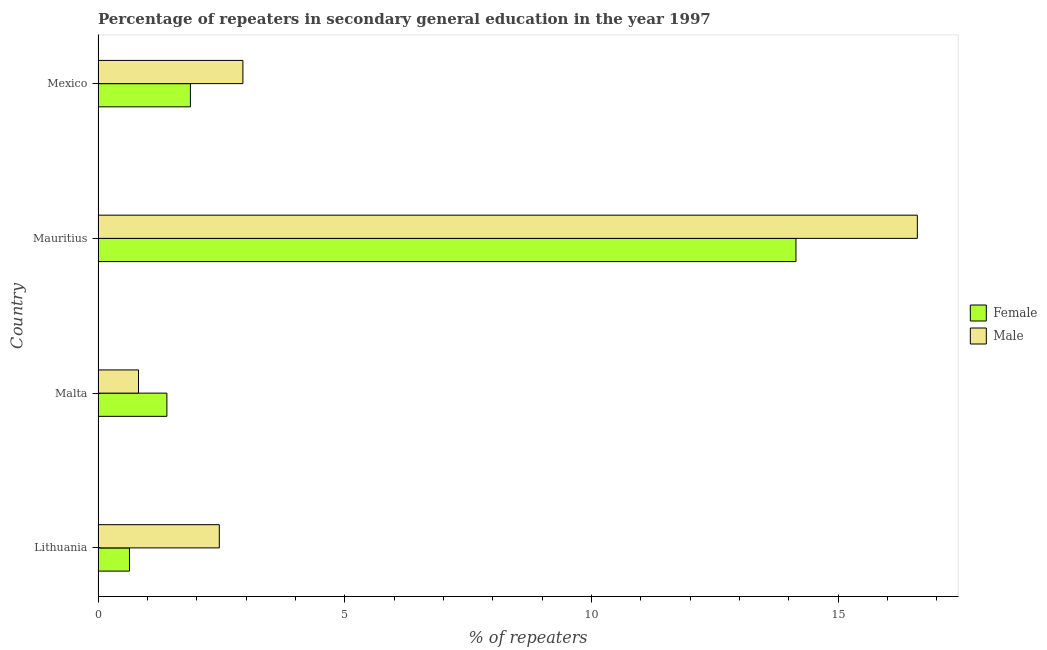How many different coloured bars are there?
Offer a very short reply. 2. How many groups of bars are there?
Your response must be concise. 4. How many bars are there on the 1st tick from the bottom?
Make the answer very short. 2. What is the percentage of male repeaters in Mauritius?
Keep it short and to the point. 16.6. Across all countries, what is the maximum percentage of female repeaters?
Your answer should be very brief. 14.14. Across all countries, what is the minimum percentage of female repeaters?
Offer a terse response. 0.64. In which country was the percentage of female repeaters maximum?
Your answer should be very brief. Mauritius. In which country was the percentage of female repeaters minimum?
Provide a short and direct response. Lithuania. What is the total percentage of male repeaters in the graph?
Provide a succinct answer. 22.82. What is the difference between the percentage of female repeaters in Malta and that in Mauritius?
Provide a succinct answer. -12.75. What is the difference between the percentage of male repeaters in Mexico and the percentage of female repeaters in Mauritius?
Provide a succinct answer. -11.21. What is the average percentage of male repeaters per country?
Your answer should be compact. 5.7. What is the difference between the percentage of male repeaters and percentage of female repeaters in Mauritius?
Offer a very short reply. 2.46. In how many countries, is the percentage of female repeaters greater than 11 %?
Provide a short and direct response. 1. What is the ratio of the percentage of male repeaters in Lithuania to that in Malta?
Offer a very short reply. 3. Is the percentage of female repeaters in Malta less than that in Mexico?
Your answer should be very brief. Yes. What is the difference between the highest and the second highest percentage of female repeaters?
Your response must be concise. 12.27. What is the difference between the highest and the lowest percentage of male repeaters?
Your answer should be compact. 15.78. In how many countries, is the percentage of male repeaters greater than the average percentage of male repeaters taken over all countries?
Make the answer very short. 1. What does the 1st bar from the top in Lithuania represents?
Ensure brevity in your answer.  Male. Are all the bars in the graph horizontal?
Give a very brief answer. Yes. How many countries are there in the graph?
Make the answer very short. 4. Does the graph contain any zero values?
Offer a very short reply. No. Does the graph contain grids?
Keep it short and to the point. No. How many legend labels are there?
Give a very brief answer. 2. How are the legend labels stacked?
Make the answer very short. Vertical. What is the title of the graph?
Ensure brevity in your answer.  Percentage of repeaters in secondary general education in the year 1997. What is the label or title of the X-axis?
Make the answer very short. % of repeaters. What is the label or title of the Y-axis?
Make the answer very short. Country. What is the % of repeaters in Female in Lithuania?
Your answer should be very brief. 0.64. What is the % of repeaters in Male in Lithuania?
Provide a short and direct response. 2.46. What is the % of repeaters of Female in Malta?
Offer a very short reply. 1.4. What is the % of repeaters in Male in Malta?
Your answer should be compact. 0.82. What is the % of repeaters of Female in Mauritius?
Keep it short and to the point. 14.14. What is the % of repeaters in Male in Mauritius?
Keep it short and to the point. 16.6. What is the % of repeaters of Female in Mexico?
Offer a terse response. 1.87. What is the % of repeaters in Male in Mexico?
Your answer should be very brief. 2.94. Across all countries, what is the maximum % of repeaters in Female?
Your response must be concise. 14.14. Across all countries, what is the maximum % of repeaters of Male?
Give a very brief answer. 16.6. Across all countries, what is the minimum % of repeaters in Female?
Your response must be concise. 0.64. Across all countries, what is the minimum % of repeaters in Male?
Ensure brevity in your answer.  0.82. What is the total % of repeaters in Female in the graph?
Give a very brief answer. 18.05. What is the total % of repeaters in Male in the graph?
Your response must be concise. 22.82. What is the difference between the % of repeaters in Female in Lithuania and that in Malta?
Provide a short and direct response. -0.76. What is the difference between the % of repeaters in Male in Lithuania and that in Malta?
Make the answer very short. 1.64. What is the difference between the % of repeaters in Female in Lithuania and that in Mauritius?
Keep it short and to the point. -13.51. What is the difference between the % of repeaters in Male in Lithuania and that in Mauritius?
Ensure brevity in your answer.  -14.15. What is the difference between the % of repeaters in Female in Lithuania and that in Mexico?
Offer a very short reply. -1.24. What is the difference between the % of repeaters in Male in Lithuania and that in Mexico?
Keep it short and to the point. -0.48. What is the difference between the % of repeaters in Female in Malta and that in Mauritius?
Your answer should be compact. -12.75. What is the difference between the % of repeaters in Male in Malta and that in Mauritius?
Give a very brief answer. -15.78. What is the difference between the % of repeaters of Female in Malta and that in Mexico?
Offer a very short reply. -0.48. What is the difference between the % of repeaters of Male in Malta and that in Mexico?
Give a very brief answer. -2.12. What is the difference between the % of repeaters of Female in Mauritius and that in Mexico?
Give a very brief answer. 12.27. What is the difference between the % of repeaters of Male in Mauritius and that in Mexico?
Offer a terse response. 13.67. What is the difference between the % of repeaters of Female in Lithuania and the % of repeaters of Male in Malta?
Your answer should be compact. -0.18. What is the difference between the % of repeaters of Female in Lithuania and the % of repeaters of Male in Mauritius?
Give a very brief answer. -15.97. What is the difference between the % of repeaters in Female in Lithuania and the % of repeaters in Male in Mexico?
Make the answer very short. -2.3. What is the difference between the % of repeaters in Female in Malta and the % of repeaters in Male in Mauritius?
Offer a terse response. -15.21. What is the difference between the % of repeaters in Female in Malta and the % of repeaters in Male in Mexico?
Your answer should be very brief. -1.54. What is the difference between the % of repeaters of Female in Mauritius and the % of repeaters of Male in Mexico?
Give a very brief answer. 11.21. What is the average % of repeaters of Female per country?
Keep it short and to the point. 4.51. What is the average % of repeaters of Male per country?
Ensure brevity in your answer.  5.7. What is the difference between the % of repeaters of Female and % of repeaters of Male in Lithuania?
Provide a short and direct response. -1.82. What is the difference between the % of repeaters of Female and % of repeaters of Male in Malta?
Keep it short and to the point. 0.58. What is the difference between the % of repeaters of Female and % of repeaters of Male in Mauritius?
Your answer should be very brief. -2.46. What is the difference between the % of repeaters of Female and % of repeaters of Male in Mexico?
Your answer should be compact. -1.06. What is the ratio of the % of repeaters in Female in Lithuania to that in Malta?
Offer a very short reply. 0.46. What is the ratio of the % of repeaters in Male in Lithuania to that in Malta?
Your answer should be compact. 3. What is the ratio of the % of repeaters of Female in Lithuania to that in Mauritius?
Keep it short and to the point. 0.04. What is the ratio of the % of repeaters in Male in Lithuania to that in Mauritius?
Offer a very short reply. 0.15. What is the ratio of the % of repeaters of Female in Lithuania to that in Mexico?
Provide a succinct answer. 0.34. What is the ratio of the % of repeaters of Male in Lithuania to that in Mexico?
Provide a succinct answer. 0.84. What is the ratio of the % of repeaters in Female in Malta to that in Mauritius?
Offer a very short reply. 0.1. What is the ratio of the % of repeaters in Male in Malta to that in Mauritius?
Make the answer very short. 0.05. What is the ratio of the % of repeaters of Female in Malta to that in Mexico?
Offer a terse response. 0.75. What is the ratio of the % of repeaters of Male in Malta to that in Mexico?
Your answer should be very brief. 0.28. What is the ratio of the % of repeaters in Female in Mauritius to that in Mexico?
Offer a very short reply. 7.56. What is the ratio of the % of repeaters of Male in Mauritius to that in Mexico?
Give a very brief answer. 5.66. What is the difference between the highest and the second highest % of repeaters of Female?
Ensure brevity in your answer.  12.27. What is the difference between the highest and the second highest % of repeaters of Male?
Provide a short and direct response. 13.67. What is the difference between the highest and the lowest % of repeaters in Female?
Offer a very short reply. 13.51. What is the difference between the highest and the lowest % of repeaters of Male?
Offer a very short reply. 15.78. 